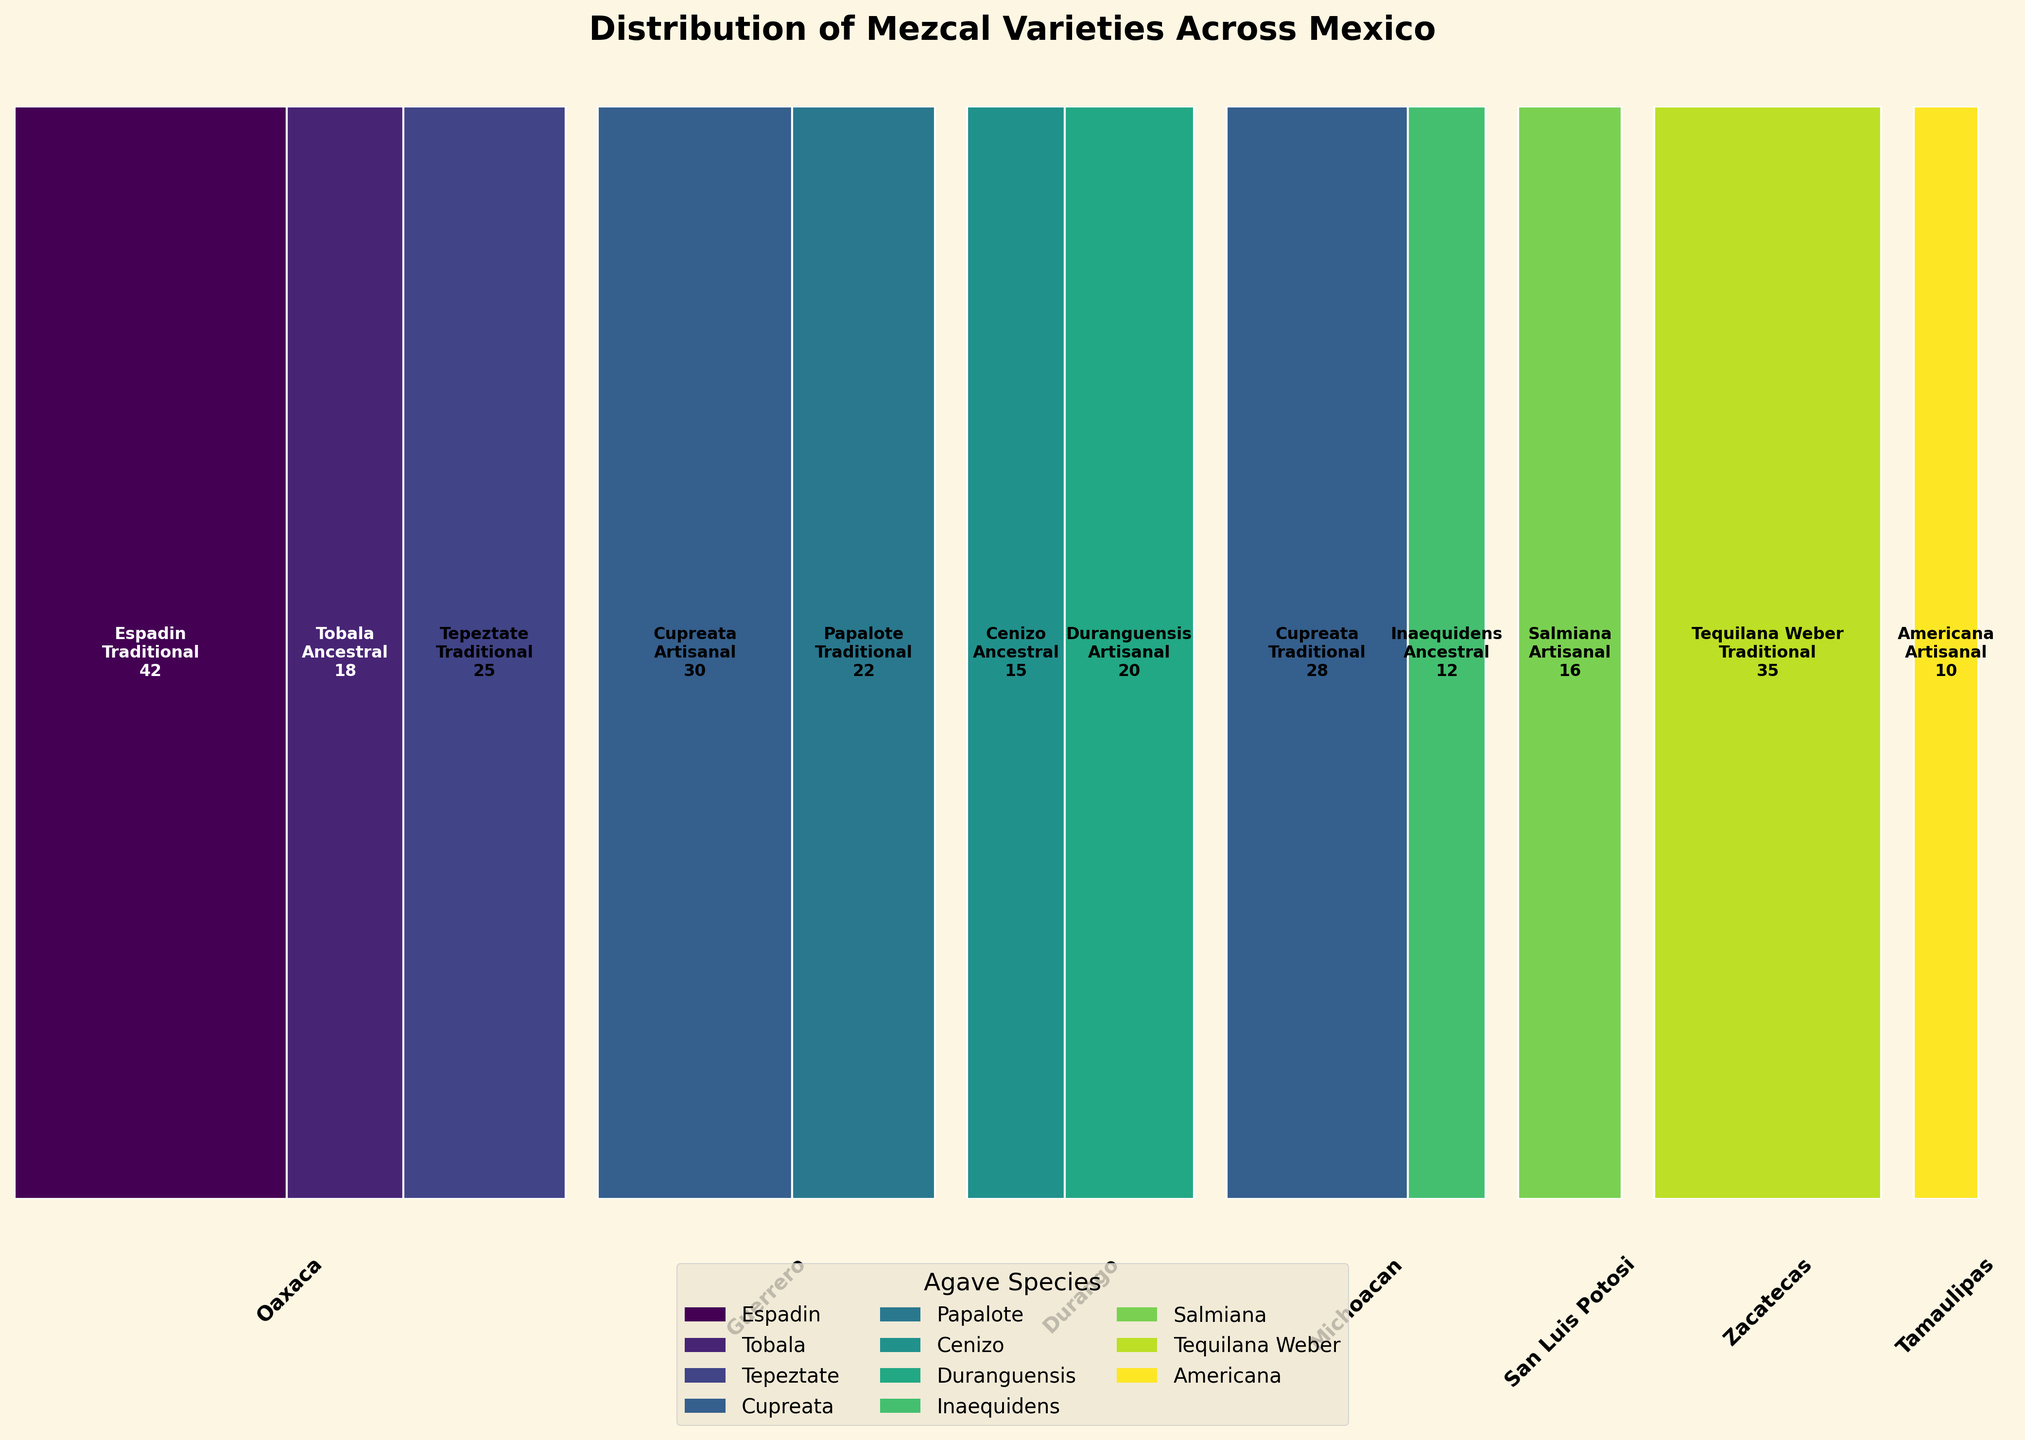Which region has the highest total count of mezcal varieties? To find the highest total count, look at the sum of all counts for each region. Oaxaca has counts of 42, 18, and 25, summing to 85. This is higher than the sum of any other region.
Answer: Oaxaca How many mezcal varieties are produced using ancestral methods across all regions? Add up the counts of mezcal produced using ancestral methods from all regions. The ancestral counts are 18 (Oaxaca), 15 (Durango), and 12 (Michoacan), totaling 45.
Answer: 45 Which agave species is most frequently used in traditional production methods across all regions? Check the counts for each agave species used in traditional methods. Espadin has 42 counts in Oaxaca, Tepeztate has 25 in Oaxaca, Papalote has 22 in Guerrero, Cupreata has 28 in Michoacan, and Tequilana Weber has 35 in Zacatecas. Tequilana Weber has the highest count of 35.
Answer: Tequilana Weber Which production method is used most and least in Tamaulipas? In Tamaulipas, only agave species Americana is produced using artisanal methods with a count of 10. Thus, artisanal is most used, and both traditional and ancestral are not used at all.
Answer: Artisanal for most, Traditional and Ancestral for least What is the difference in count between traditional and artisanal production methods in Guerrero? Guerrero has 22 counts for traditional (Papalote) and 30 counts for artisanal (Cupreata). The difference is 30 - 22 = 8.
Answer: 8 How many different agave species are used across all regions? Identify unique agave species from the data: Espadin, Tobala, Tepeztate, Cupreata, Papalote, Cenizo, Duranguensis, Inaequidens, Salmiana, Tequilana Weber, and Americana, which sum to 11.
Answer: 11 Which region exclusively uses one production method? Check the production methods for each region. Tamaulipas uses only the artisanal method (Americana).
Answer: Tamaulipas What is the total count of mezcal varieties produced in Durango? Sum the counts for the agave species in Durango: 15 (Cenizo, ancestral) and 20 (Duranguensis, artisanal), totaling 35.
Answer: 35 Which agave species has the smallest total count of mezcal varieties produced? Compare the total counts across all regions for each species. Inaequidens has the smallest total count of 12 in Michoacan.
Answer: Inaequidens 